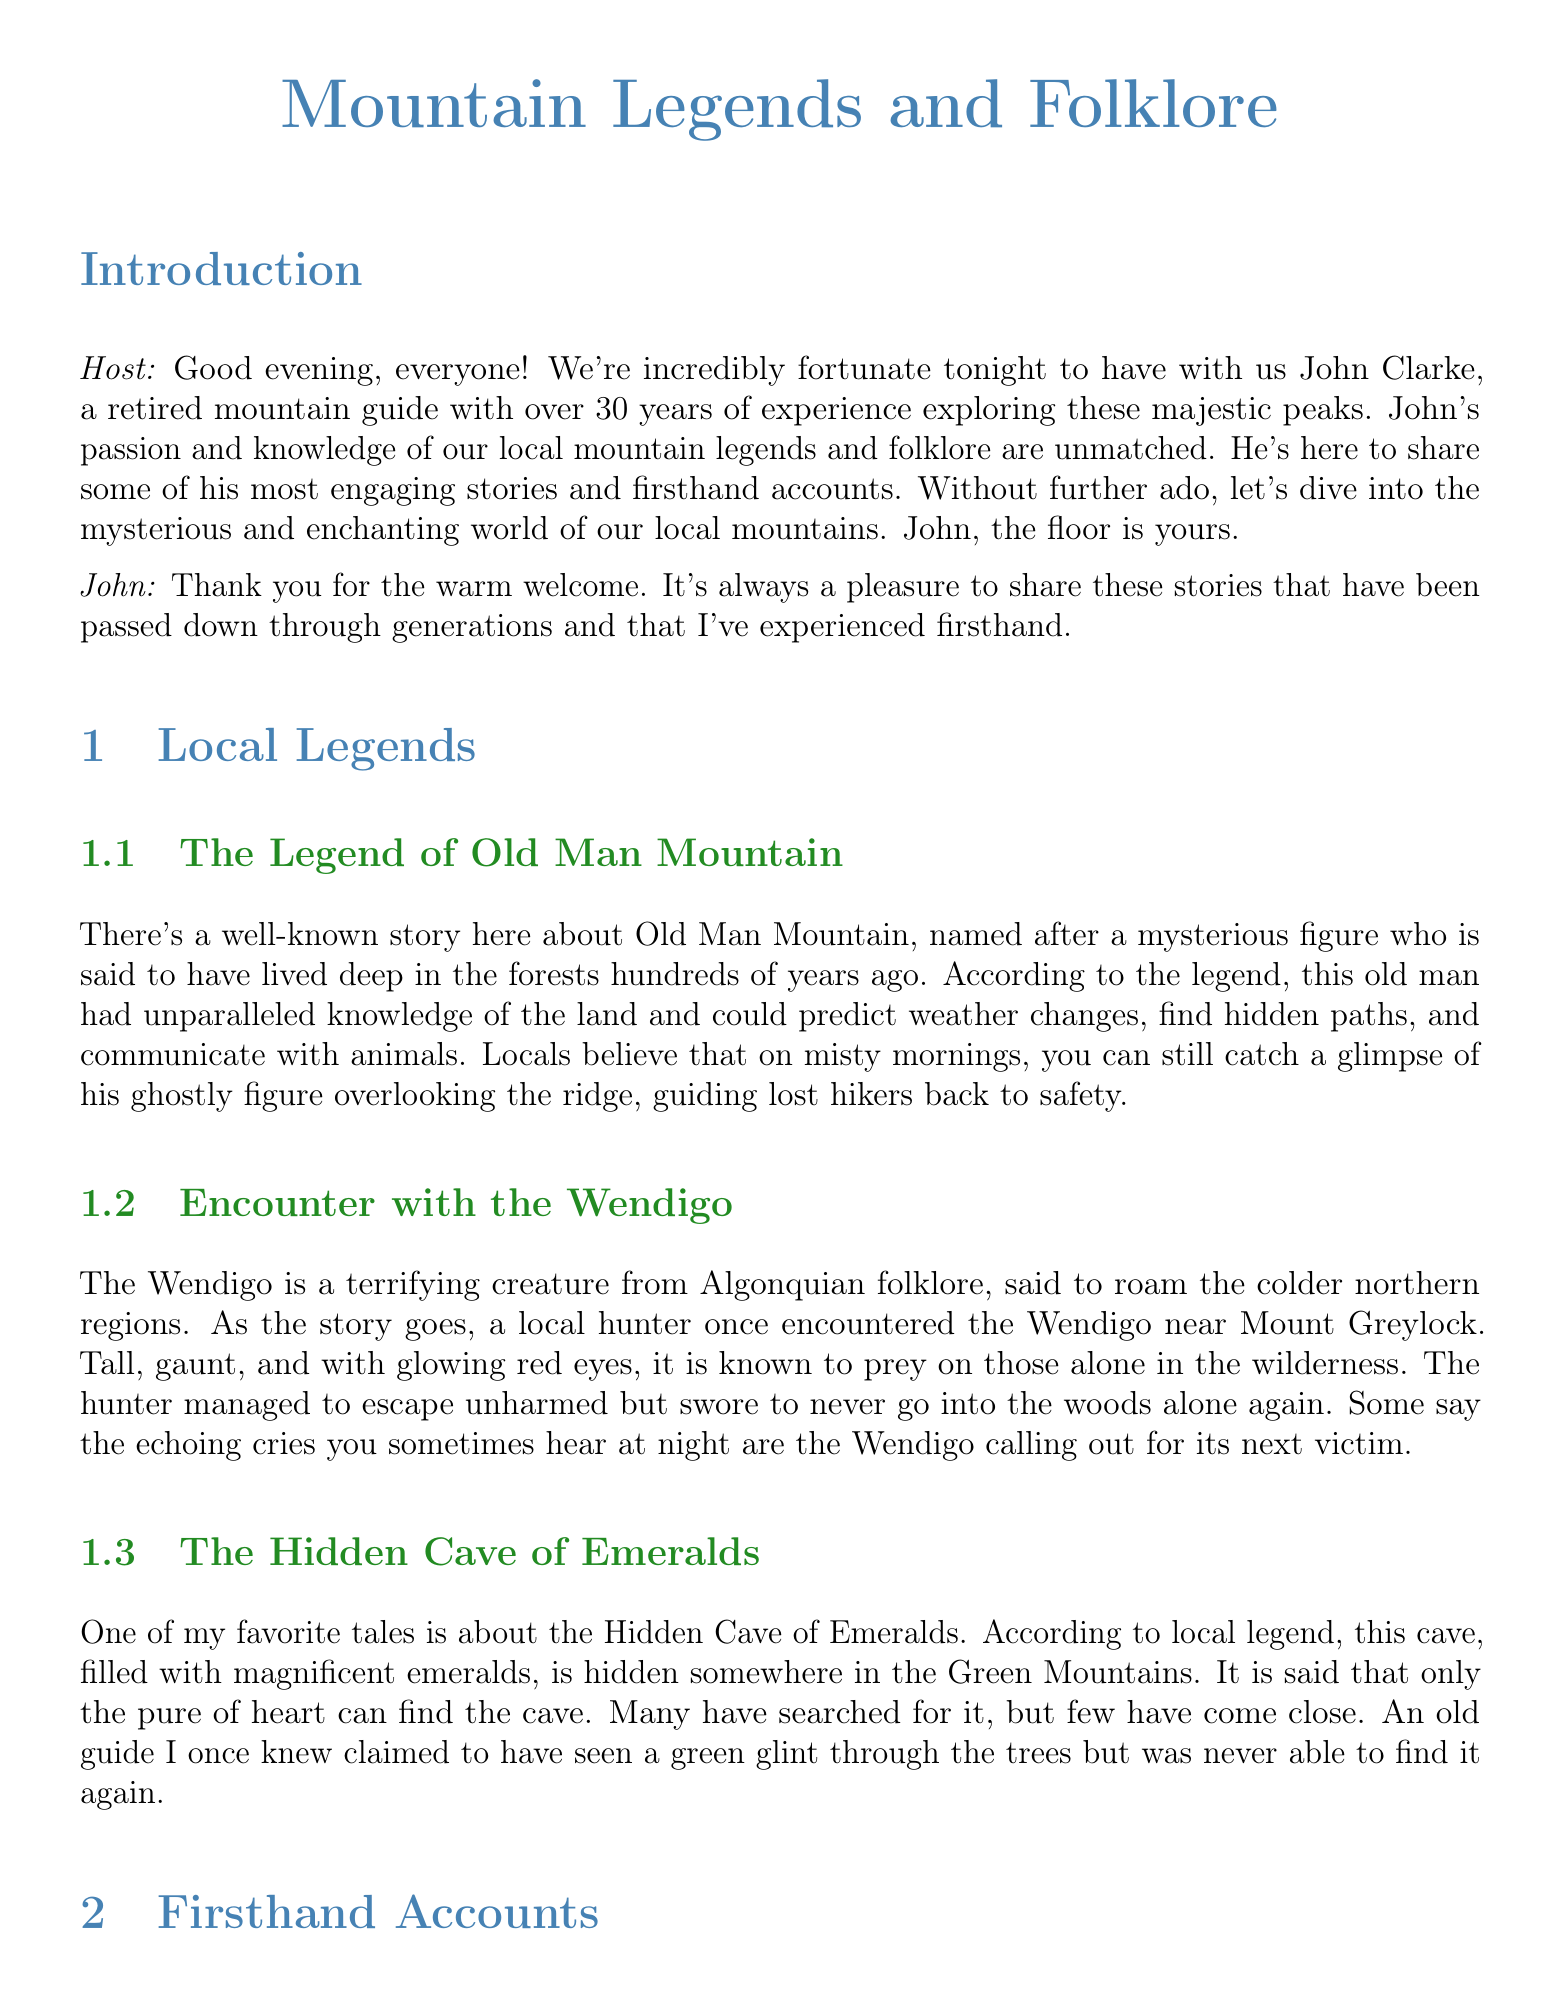What is the name of the retired mountain guide? The retired mountain guide is introduced as John Clarke.
Answer: John Clarke What legend involves a mysterious figure who guides lost hikers? This legend is known as the Legend of Old Man Mountain.
Answer: Old Man Mountain What creature is said to roam the colder northern regions in folklore? The creature mentioned is the Wendigo.
Answer: Wendigo How many years of experience does John have as a mountain guide? John has over 30 years of experience exploring the mountains.
Answer: 30 years What is claimed to be hidden in the Hidden Cave of Emeralds? The Hidden Cave of Emeralds is said to be filled with magnificent emeralds.
Answer: Emeralds What did the lost hiker report seeing that led him to a cave? The lost hiker said he was led there by a woman in white.
Answer: Woman in white What strange sounds did John hear while camping near Franconia Notch? John heard sounds that resembled footsteps outside his tent.
Answer: Footsteps What does John say about the mountains' influence on experiences? John comments that the mountains play tricks on you, creating eerie melodies.
Answer: Tricks on you What is the purpose of inviting John to share his stories? The purpose is to share engaging stories and firsthand accounts about local folklore.
Answer: Share engaging stories 